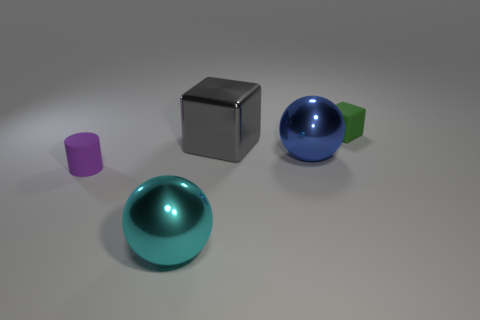There is a tiny thing right of the big metal block; does it have the same shape as the tiny object that is in front of the big blue ball?
Make the answer very short. No. What size is the green matte thing?
Your answer should be compact. Small. There is a tiny object that is left of the tiny matte object that is to the right of the big metallic object that is to the left of the big gray thing; what is it made of?
Give a very brief answer. Rubber. What number of other things are there of the same color as the shiny cube?
Make the answer very short. 0. What number of green things are big things or small matte blocks?
Your response must be concise. 1. What is the cube that is to the right of the blue sphere made of?
Offer a very short reply. Rubber. Is the big object left of the gray cube made of the same material as the small purple cylinder?
Offer a very short reply. No. The big cyan metal object has what shape?
Provide a short and direct response. Sphere. There is a large shiny sphere that is behind the metal ball left of the large metallic block; what number of gray metallic objects are in front of it?
Make the answer very short. 0. What number of other things are there of the same material as the purple cylinder
Your response must be concise. 1. 